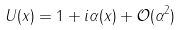<formula> <loc_0><loc_0><loc_500><loc_500>U ( x ) = 1 + i \alpha ( x ) + { \mathcal { O } } ( \alpha ^ { 2 } )</formula> 